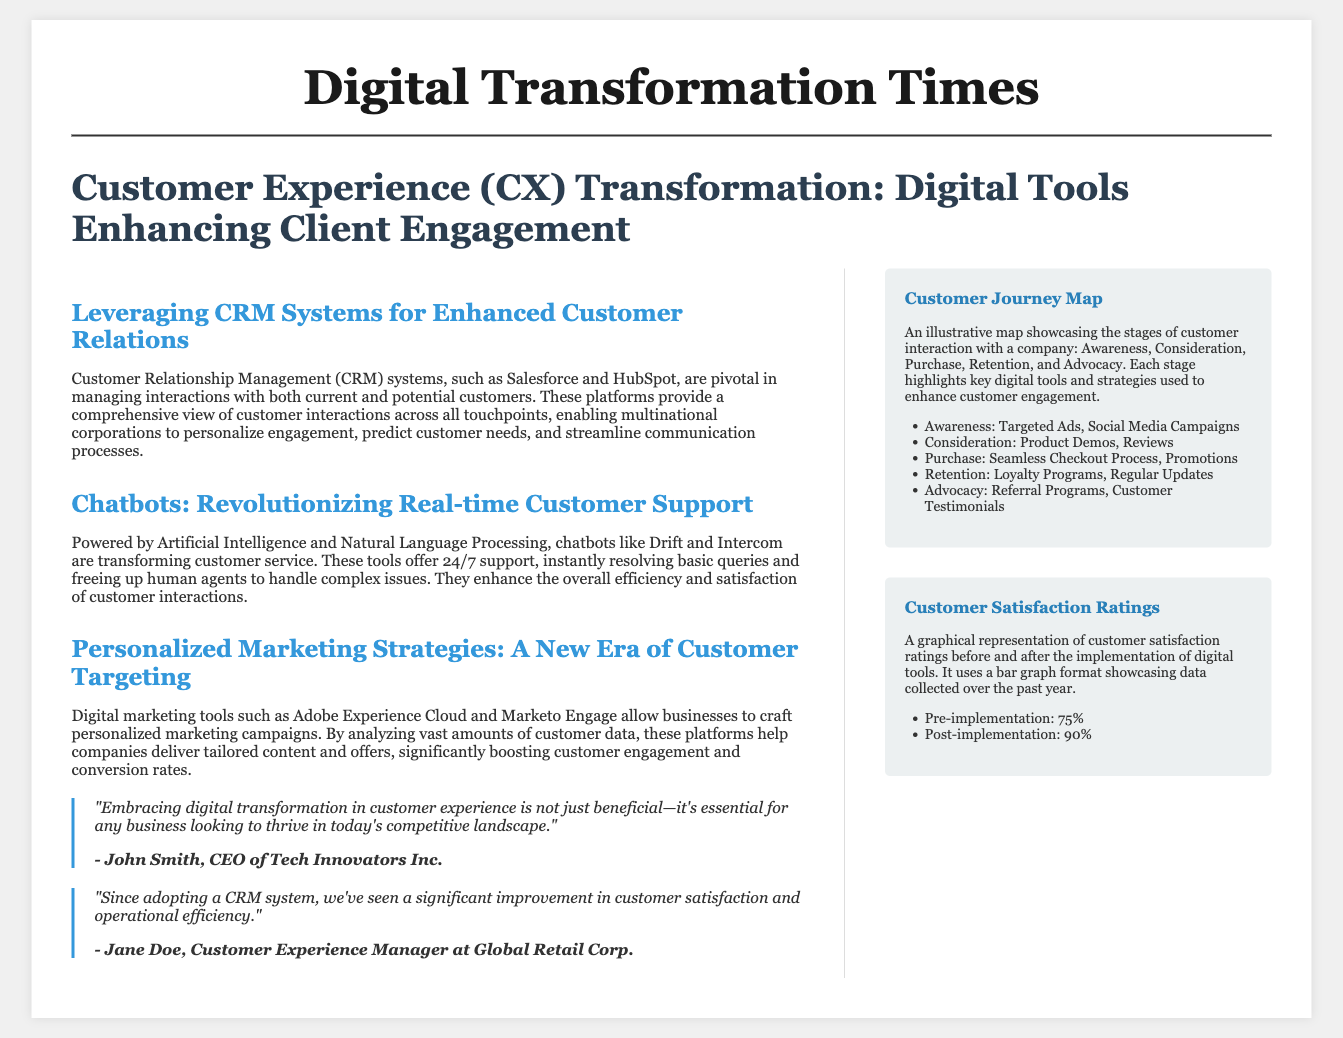What is the main topic of the article? The main topic is about how digital tools are enhancing client engagement through customer experience transformation.
Answer: Customer Experience (CX) Transformation What does CRM stand for? CRM stands for Customer Relationship Management, which refers to systems that manage interactions with current and potential customers.
Answer: Customer Relationship Management Which two companies are mentioned as CRM systems? The document explicitly mentions Salesforce and HubSpot as examples of CRM systems.
Answer: Salesforce and HubSpot What is the customer satisfaction rating before implementation? The document states that the customer satisfaction rating before the implementation of digital tools was 75%.
Answer: 75% What is the customer satisfaction rating after implementation? According to the document, the customer satisfaction rating after implementing digital tools rose to 90%.
Answer: 90% What type of support do chatbots provide? The document indicates that chatbots provide real-time customer support and instantly resolve basic queries.
Answer: Real-time customer support Which marketing tools are mentioned for personalized campaigns? The document references Adobe Experience Cloud and Marketo Engage as tools for crafting personalized marketing strategies.
Answer: Adobe Experience Cloud and Marketo Engage What are the stages of the customer journey map? The stages outlined in the customer journey map are Awareness, Consideration, Purchase, Retention, and Advocacy.
Answer: Awareness, Consideration, Purchase, Retention, Advocacy Who is quoted about the importance of digital transformation? John Smith, the CEO of Tech Innovators Inc., is quoted regarding the importance of embracing digital transformation.
Answer: John Smith What visual representation is used to display customer satisfaction ratings? The document states that a bar graph format is used to represent customer satisfaction ratings before and after the implementation.
Answer: Bar graph format 